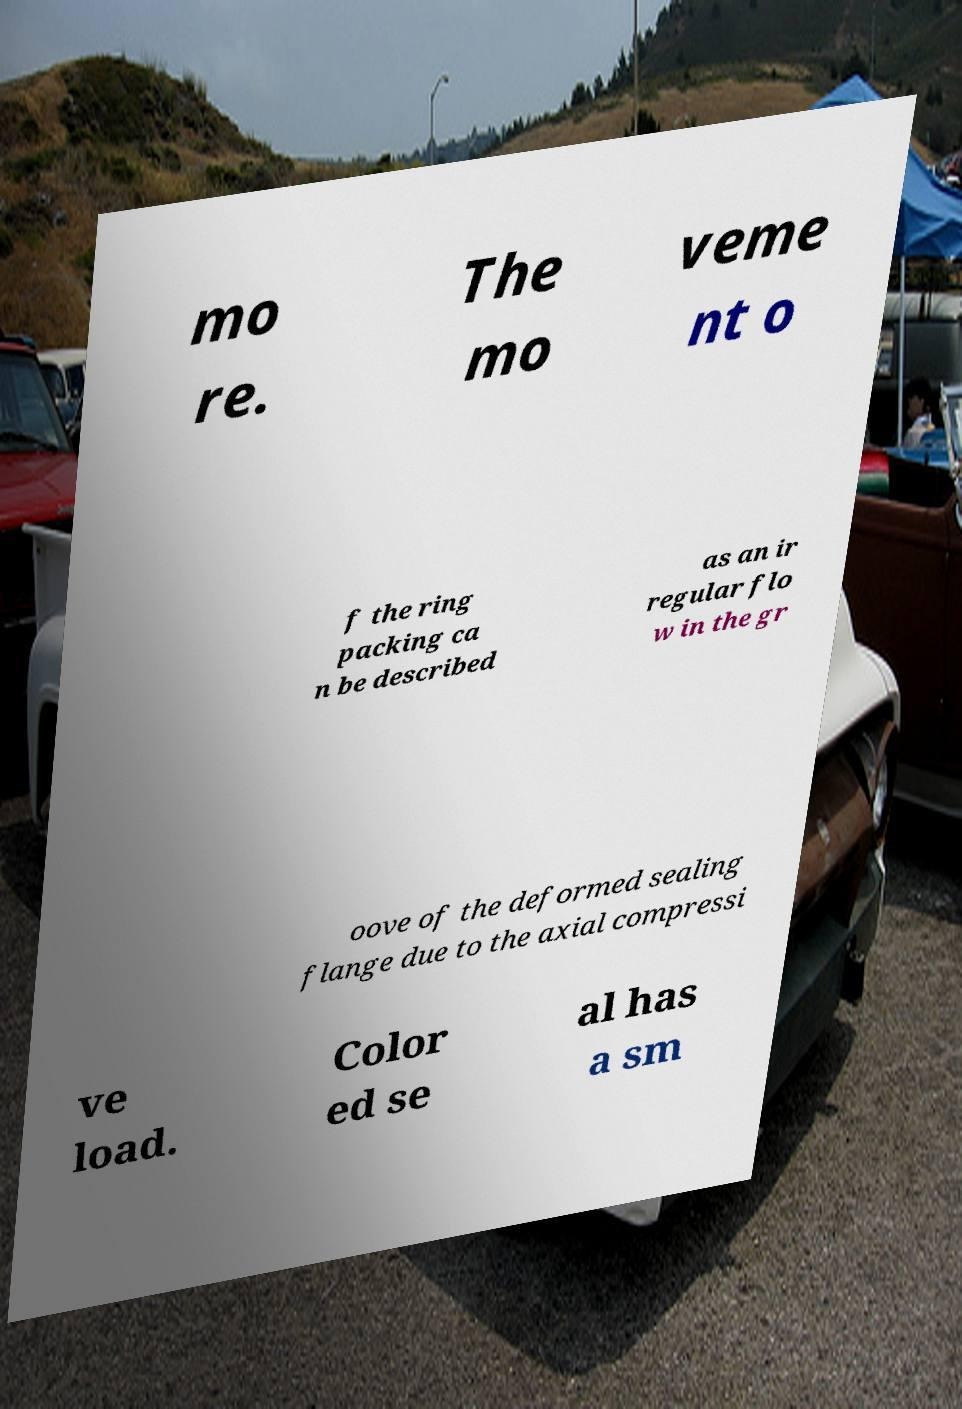There's text embedded in this image that I need extracted. Can you transcribe it verbatim? mo re. The mo veme nt o f the ring packing ca n be described as an ir regular flo w in the gr oove of the deformed sealing flange due to the axial compressi ve load. Color ed se al has a sm 